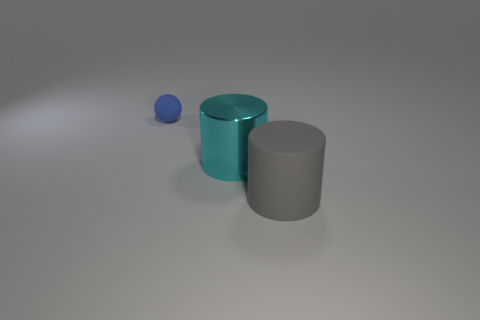Add 3 blue balls. How many objects exist? 6 Subtract all cylinders. How many objects are left? 1 Add 2 large shiny spheres. How many large shiny spheres exist? 2 Subtract 0 purple cylinders. How many objects are left? 3 Subtract all small yellow metallic cylinders. Subtract all large cyan objects. How many objects are left? 2 Add 2 big rubber cylinders. How many big rubber cylinders are left? 3 